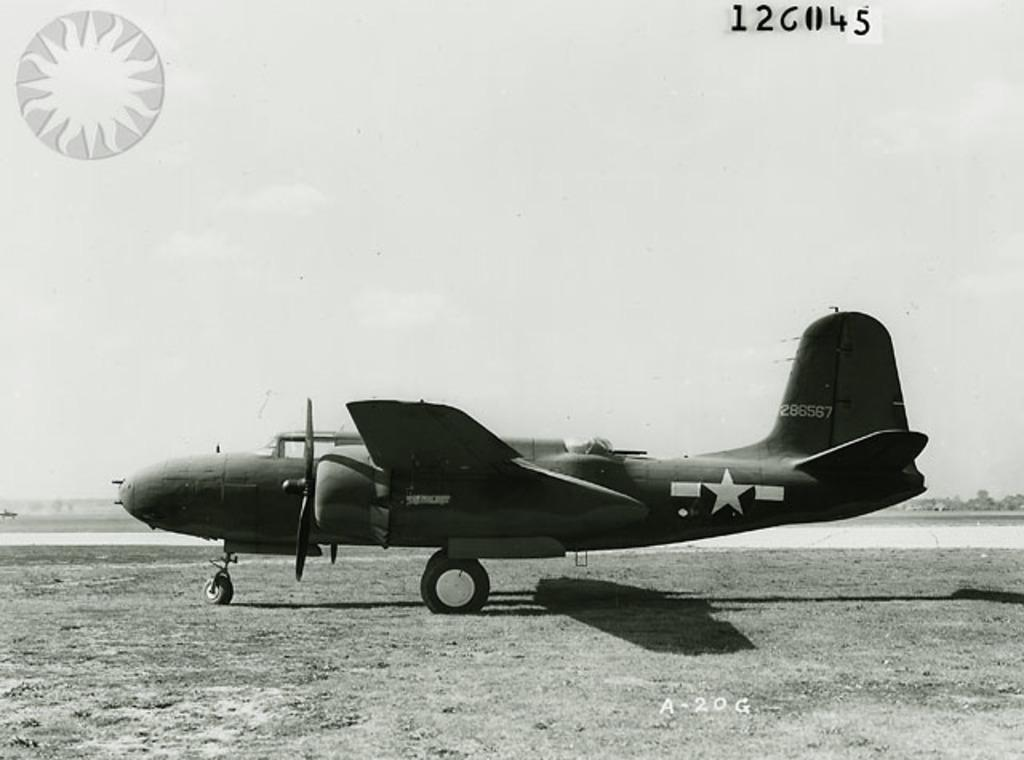Provide a one-sentence caption for the provided image. Airplane with numbers 286567 in white on the back of the airplane. 